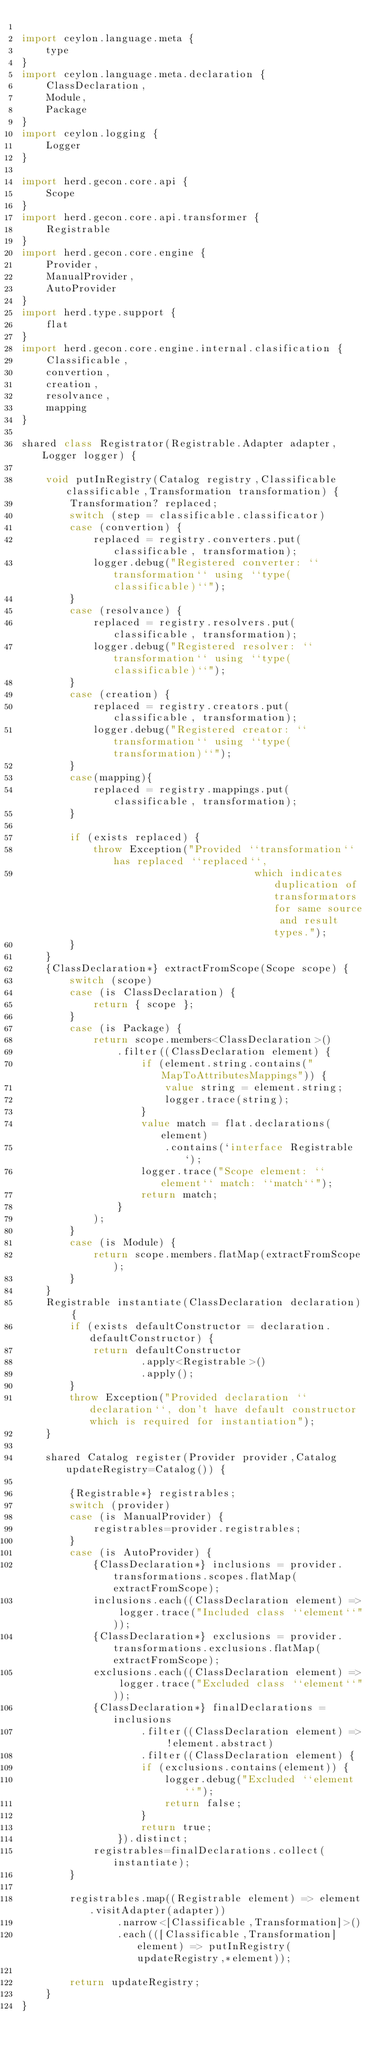Convert code to text. <code><loc_0><loc_0><loc_500><loc_500><_Ceylon_>
import ceylon.language.meta {
	type
}
import ceylon.language.meta.declaration {
	ClassDeclaration,
	Module,
	Package
}
import ceylon.logging {
	Logger
}

import herd.gecon.core.api {
	Scope
}
import herd.gecon.core.api.transformer {
	Registrable
}
import herd.gecon.core.engine {
	Provider,
	ManualProvider,
	AutoProvider
}
import herd.type.support {
	flat
}
import herd.gecon.core.engine.internal.clasification {
	Classificable,
	convertion,
	creation,
	resolvance,
	mapping
}

shared class Registrator(Registrable.Adapter adapter, Logger logger) {
	
	void putInRegistry(Catalog registry,Classificable classificable,Transformation transformation) {
		Transformation? replaced;
		switch (step = classificable.classificator)
		case (convertion) {
			replaced = registry.converters.put(classificable, transformation);
			logger.debug("Registered converter: ``transformation`` using ``type(classificable)``");
		}
		case (resolvance) {
			replaced = registry.resolvers.put(classificable, transformation);
			logger.debug("Registered resolver: ``transformation`` using ``type(classificable)``");
		}
		case (creation) {
			replaced = registry.creators.put(classificable, transformation);
			logger.debug("Registered creator: ``transformation`` using ``type(transformation)``");
		}
		case(mapping){
			replaced = registry.mappings.put(classificable, transformation);
		}
		
		if (exists replaced) {
			throw Exception("Provided ``transformation`` has replaced ``replaced``,
			                           which indicates duplication of transformators for same source and result types.");
		}
	}
	{ClassDeclaration*} extractFromScope(Scope scope) {
		switch (scope)
		case (is ClassDeclaration) {
			return { scope };
		}
		case (is Package) {
			return scope.members<ClassDeclaration>()
				.filter((ClassDeclaration element) {
					if (element.string.contains("MapToAttributesMappings")) {
						value string = element.string;
						logger.trace(string);
					}
					value match = flat.declarations(element)
						.contains(`interface Registrable`);
					logger.trace("Scope element: ``element`` match: ``match``");
					return match;
				}
			);
		}
		case (is Module) {
			return scope.members.flatMap(extractFromScope);
		}
	}
	Registrable instantiate(ClassDeclaration declaration) {
		if (exists defaultConstructor = declaration.defaultConstructor) {
			return defaultConstructor
					.apply<Registrable>()
					.apply();
		}
		throw Exception("Provided declaration ``declaration``, don't have default constructor which is required for instantiation");
	}
	
	shared Catalog register(Provider provider,Catalog updateRegistry=Catalog()) {
		
		{Registrable*} registrables;
		switch (provider)
		case (is ManualProvider) {
			registrables=provider.registrables;
		}
		case (is AutoProvider) {
			{ClassDeclaration*} inclusions = provider.transformations.scopes.flatMap(extractFromScope);
			inclusions.each((ClassDeclaration element) => logger.trace("Included class ``element``"));
			{ClassDeclaration*} exclusions = provider.transformations.exclusions.flatMap(extractFromScope);
			exclusions.each((ClassDeclaration element) => logger.trace("Excluded class ``element``"));
			{ClassDeclaration*} finalDeclarations = inclusions
					.filter((ClassDeclaration element) => !element.abstract)
					.filter((ClassDeclaration element) {
					if (exclusions.contains(element)) {
						logger.debug("Excluded ``element``");
						return false;
					}
					return true;
				}).distinct;
			registrables=finalDeclarations.collect(instantiate);
		}
		
		registrables.map((Registrable element) => element.visitAdapter(adapter))
				.narrow<[Classificable,Transformation]>()
				.each(([Classificable,Transformation] element) => putInRegistry(updateRegistry,*element));
		
		return updateRegistry;
	}
}
</code> 